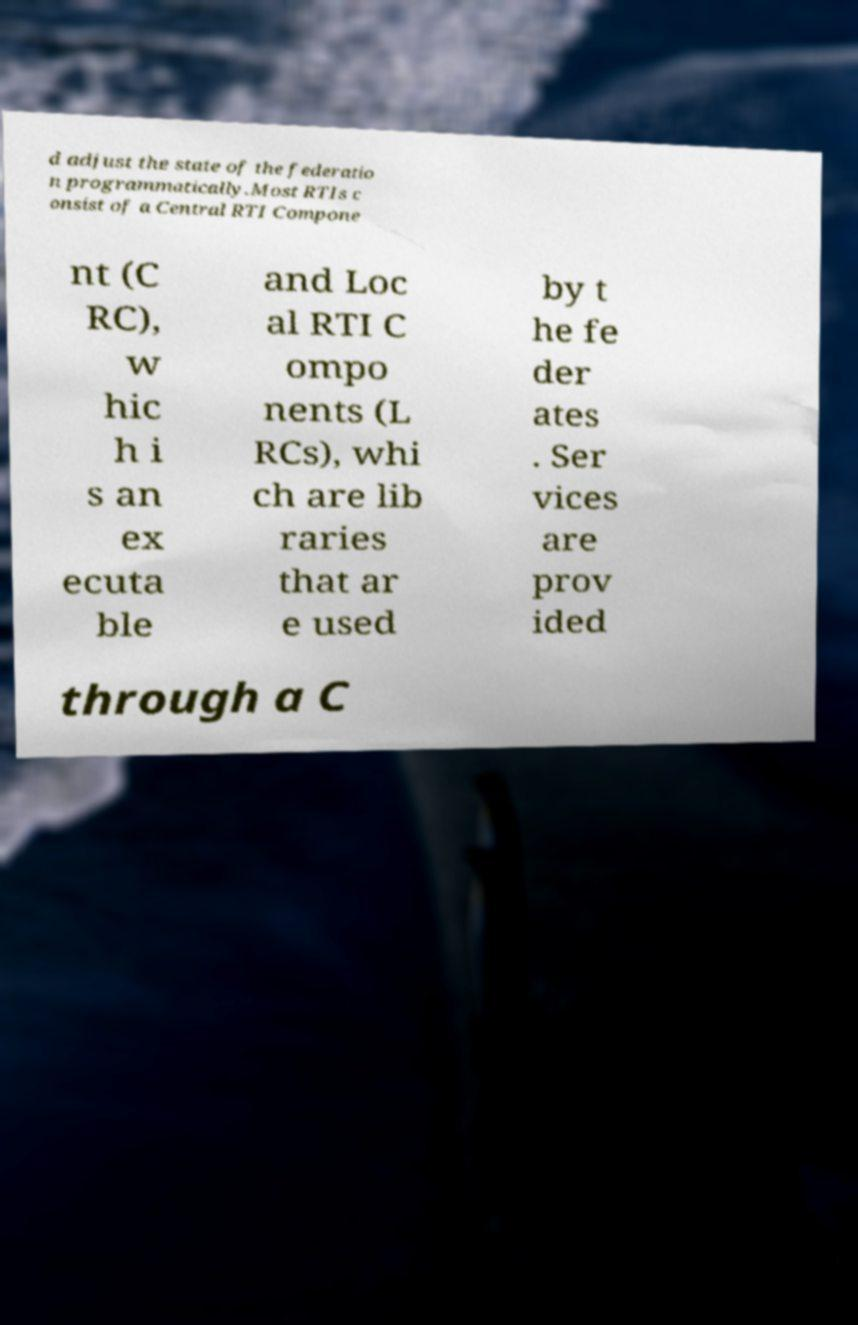Can you read and provide the text displayed in the image?This photo seems to have some interesting text. Can you extract and type it out for me? d adjust the state of the federatio n programmatically.Most RTIs c onsist of a Central RTI Compone nt (C RC), w hic h i s an ex ecuta ble and Loc al RTI C ompo nents (L RCs), whi ch are lib raries that ar e used by t he fe der ates . Ser vices are prov ided through a C 